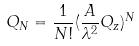Convert formula to latex. <formula><loc_0><loc_0><loc_500><loc_500>Q _ { N } = \frac { 1 } { N ! } ( \frac { A } { \lambda ^ { 2 } } Q _ { z } ) ^ { N }</formula> 